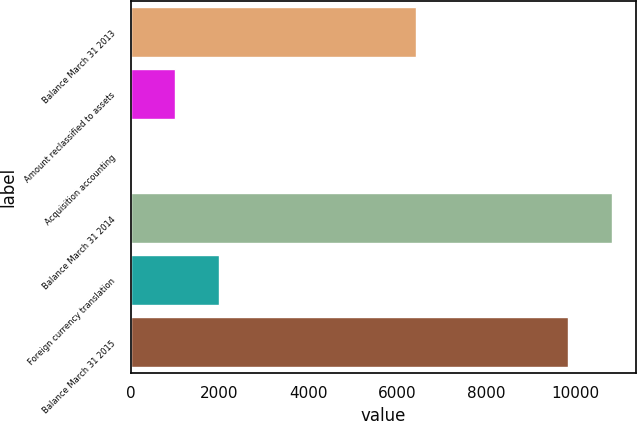Convert chart to OTSL. <chart><loc_0><loc_0><loc_500><loc_500><bar_chart><fcel>Balance March 31 2013<fcel>Amount reclassified to assets<fcel>Acquisition accounting<fcel>Balance March 31 2014<fcel>Foreign currency translation<fcel>Balance March 31 2015<nl><fcel>6405<fcel>993.6<fcel>1<fcel>10809.6<fcel>1986.2<fcel>9817<nl></chart> 